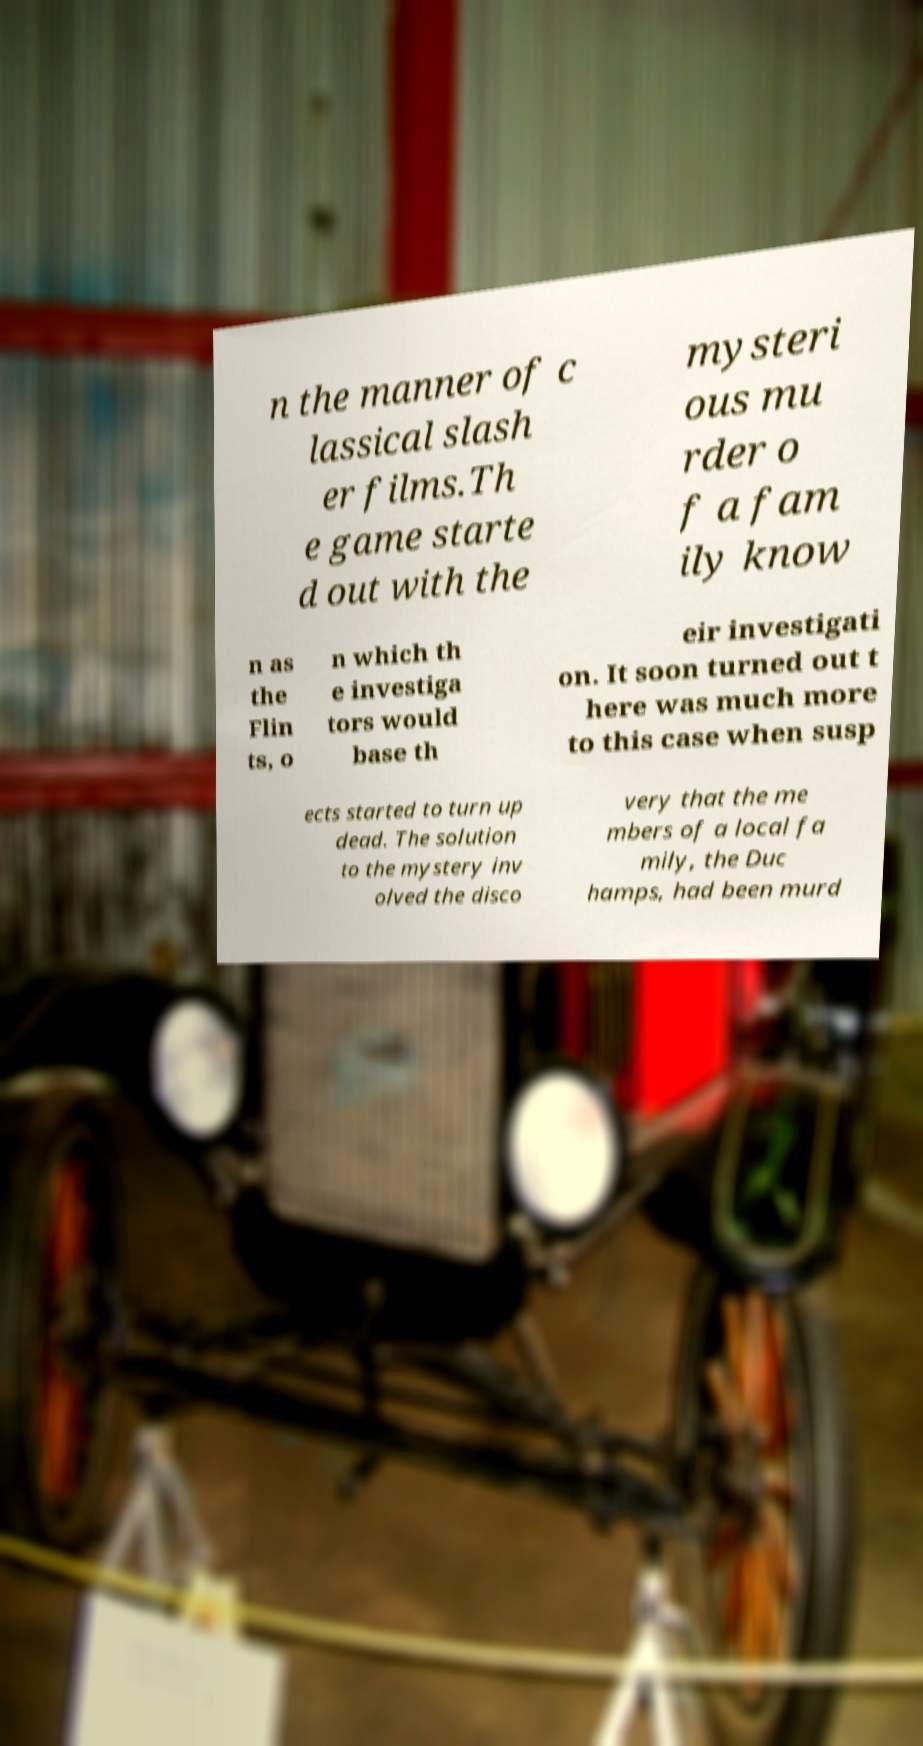Please read and relay the text visible in this image. What does it say? n the manner of c lassical slash er films.Th e game starte d out with the mysteri ous mu rder o f a fam ily know n as the Flin ts, o n which th e investiga tors would base th eir investigati on. It soon turned out t here was much more to this case when susp ects started to turn up dead. The solution to the mystery inv olved the disco very that the me mbers of a local fa mily, the Duc hamps, had been murd 